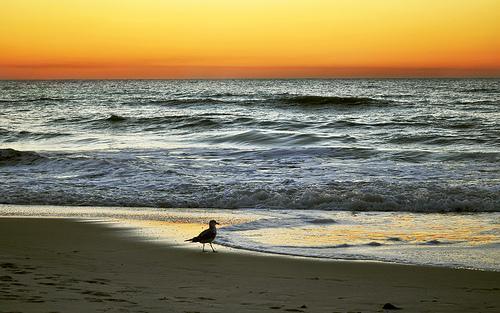How many birds are there?
Give a very brief answer. 1. 